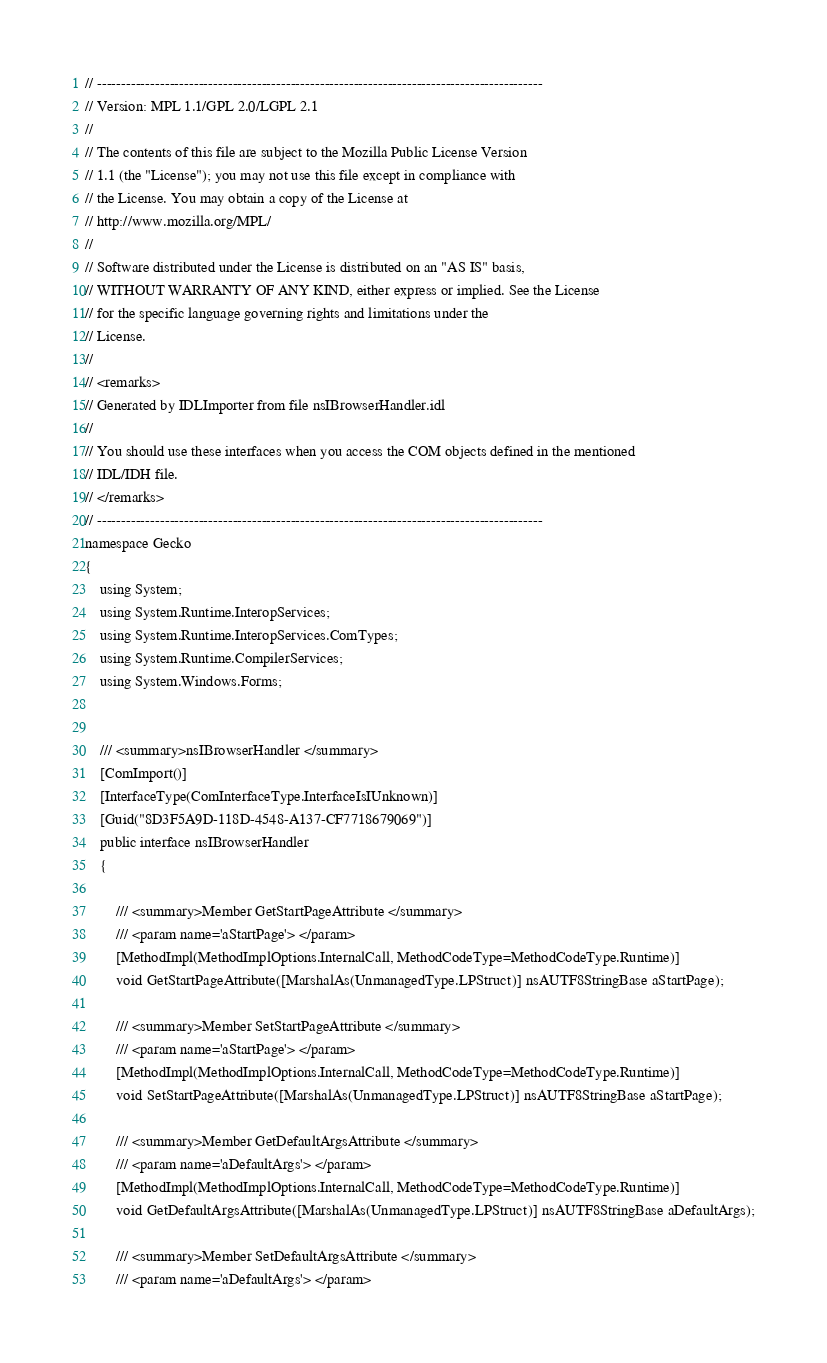Convert code to text. <code><loc_0><loc_0><loc_500><loc_500><_C#_>// --------------------------------------------------------------------------------------------
// Version: MPL 1.1/GPL 2.0/LGPL 2.1
// 
// The contents of this file are subject to the Mozilla Public License Version
// 1.1 (the "License"); you may not use this file except in compliance with
// the License. You may obtain a copy of the License at
// http://www.mozilla.org/MPL/
// 
// Software distributed under the License is distributed on an "AS IS" basis,
// WITHOUT WARRANTY OF ANY KIND, either express or implied. See the License
// for the specific language governing rights and limitations under the
// License.
// 
// <remarks>
// Generated by IDLImporter from file nsIBrowserHandler.idl
// 
// You should use these interfaces when you access the COM objects defined in the mentioned
// IDL/IDH file.
// </remarks>
// --------------------------------------------------------------------------------------------
namespace Gecko
{
	using System;
	using System.Runtime.InteropServices;
	using System.Runtime.InteropServices.ComTypes;
	using System.Runtime.CompilerServices;
	using System.Windows.Forms;
	
	
	/// <summary>nsIBrowserHandler </summary>
	[ComImport()]
	[InterfaceType(ComInterfaceType.InterfaceIsIUnknown)]
	[Guid("8D3F5A9D-118D-4548-A137-CF7718679069")]
	public interface nsIBrowserHandler
	{
		
		/// <summary>Member GetStartPageAttribute </summary>
		/// <param name='aStartPage'> </param>
		[MethodImpl(MethodImplOptions.InternalCall, MethodCodeType=MethodCodeType.Runtime)]
		void GetStartPageAttribute([MarshalAs(UnmanagedType.LPStruct)] nsAUTF8StringBase aStartPage);
		
		/// <summary>Member SetStartPageAttribute </summary>
		/// <param name='aStartPage'> </param>
		[MethodImpl(MethodImplOptions.InternalCall, MethodCodeType=MethodCodeType.Runtime)]
		void SetStartPageAttribute([MarshalAs(UnmanagedType.LPStruct)] nsAUTF8StringBase aStartPage);
		
		/// <summary>Member GetDefaultArgsAttribute </summary>
		/// <param name='aDefaultArgs'> </param>
		[MethodImpl(MethodImplOptions.InternalCall, MethodCodeType=MethodCodeType.Runtime)]
		void GetDefaultArgsAttribute([MarshalAs(UnmanagedType.LPStruct)] nsAUTF8StringBase aDefaultArgs);
		
		/// <summary>Member SetDefaultArgsAttribute </summary>
		/// <param name='aDefaultArgs'> </param></code> 